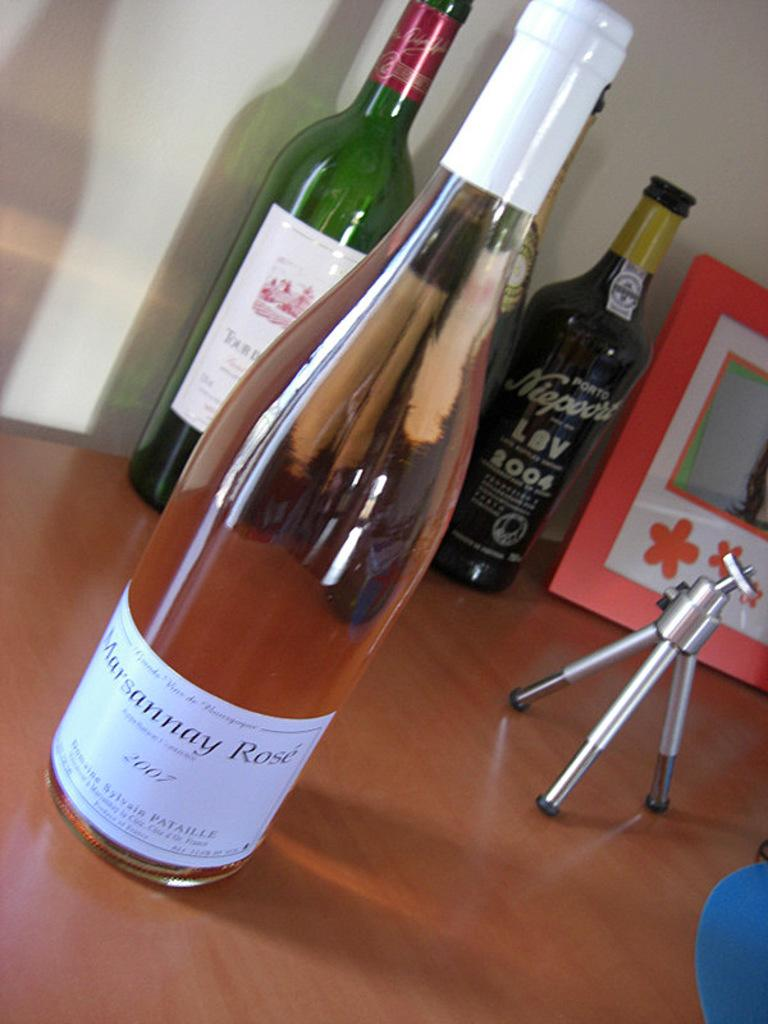<image>
Render a clear and concise summary of the photo. A wine bottle of rose with the year of 2007. 